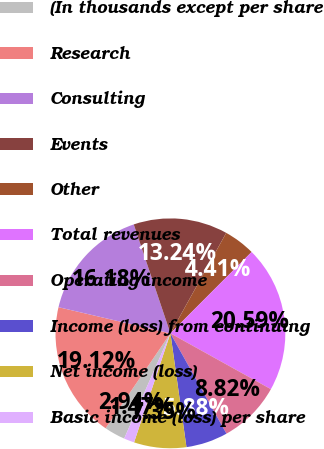Convert chart. <chart><loc_0><loc_0><loc_500><loc_500><pie_chart><fcel>(In thousands except per share<fcel>Research<fcel>Consulting<fcel>Events<fcel>Other<fcel>Total revenues<fcel>Operating income<fcel>Income (loss) from continuing<fcel>Net income (loss)<fcel>Basic income (loss) per share<nl><fcel>2.94%<fcel>19.12%<fcel>16.18%<fcel>13.24%<fcel>4.41%<fcel>20.59%<fcel>8.82%<fcel>5.88%<fcel>7.35%<fcel>1.47%<nl></chart> 